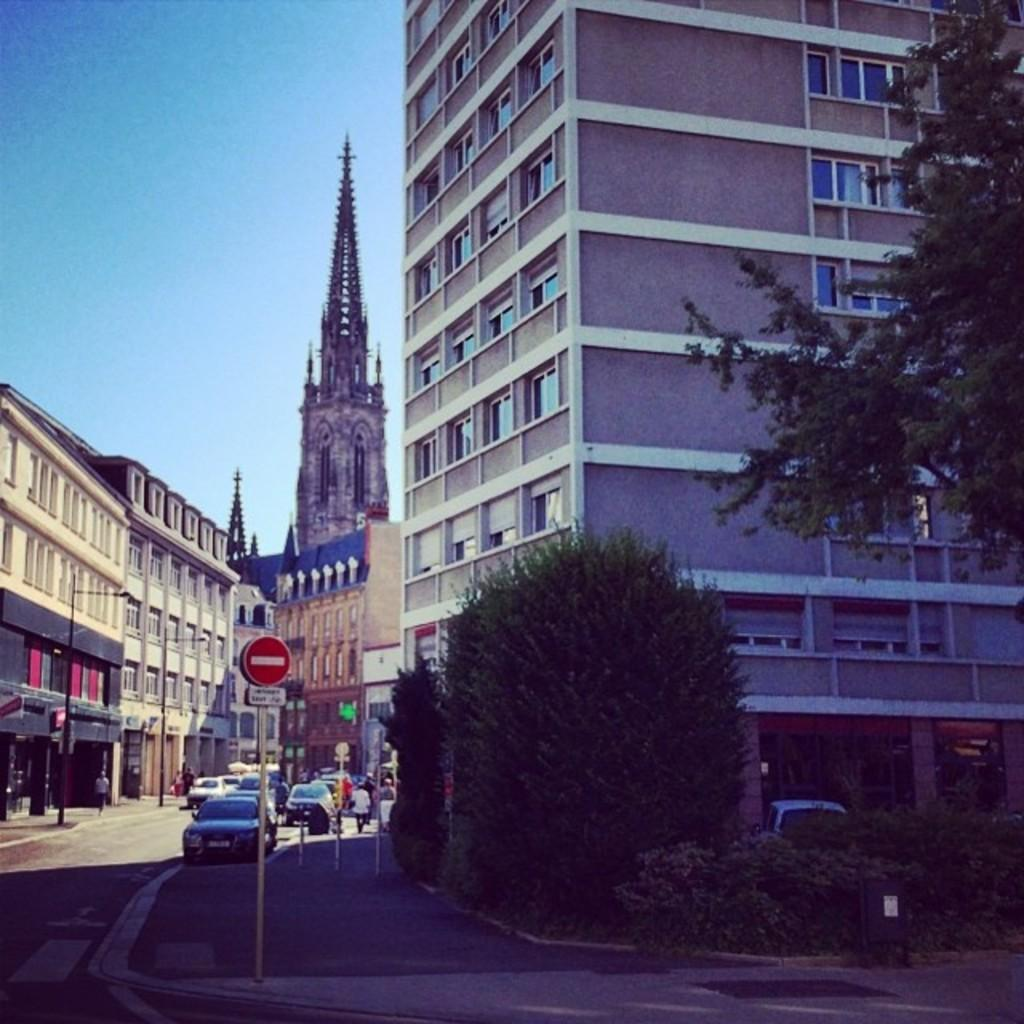What type of natural elements can be seen in the image? There are trees and plants in the image. What man-made structures are visible in the image? There are boards on a pole, vehicles on the road, people, buildings, windows, and objects in the image. What is the condition of the sky in the image? The sky is visible in the image. What type of door can be seen in the image? There is no door present in the image. Are there any mittens visible in the image? There are no mittens present in the image. 